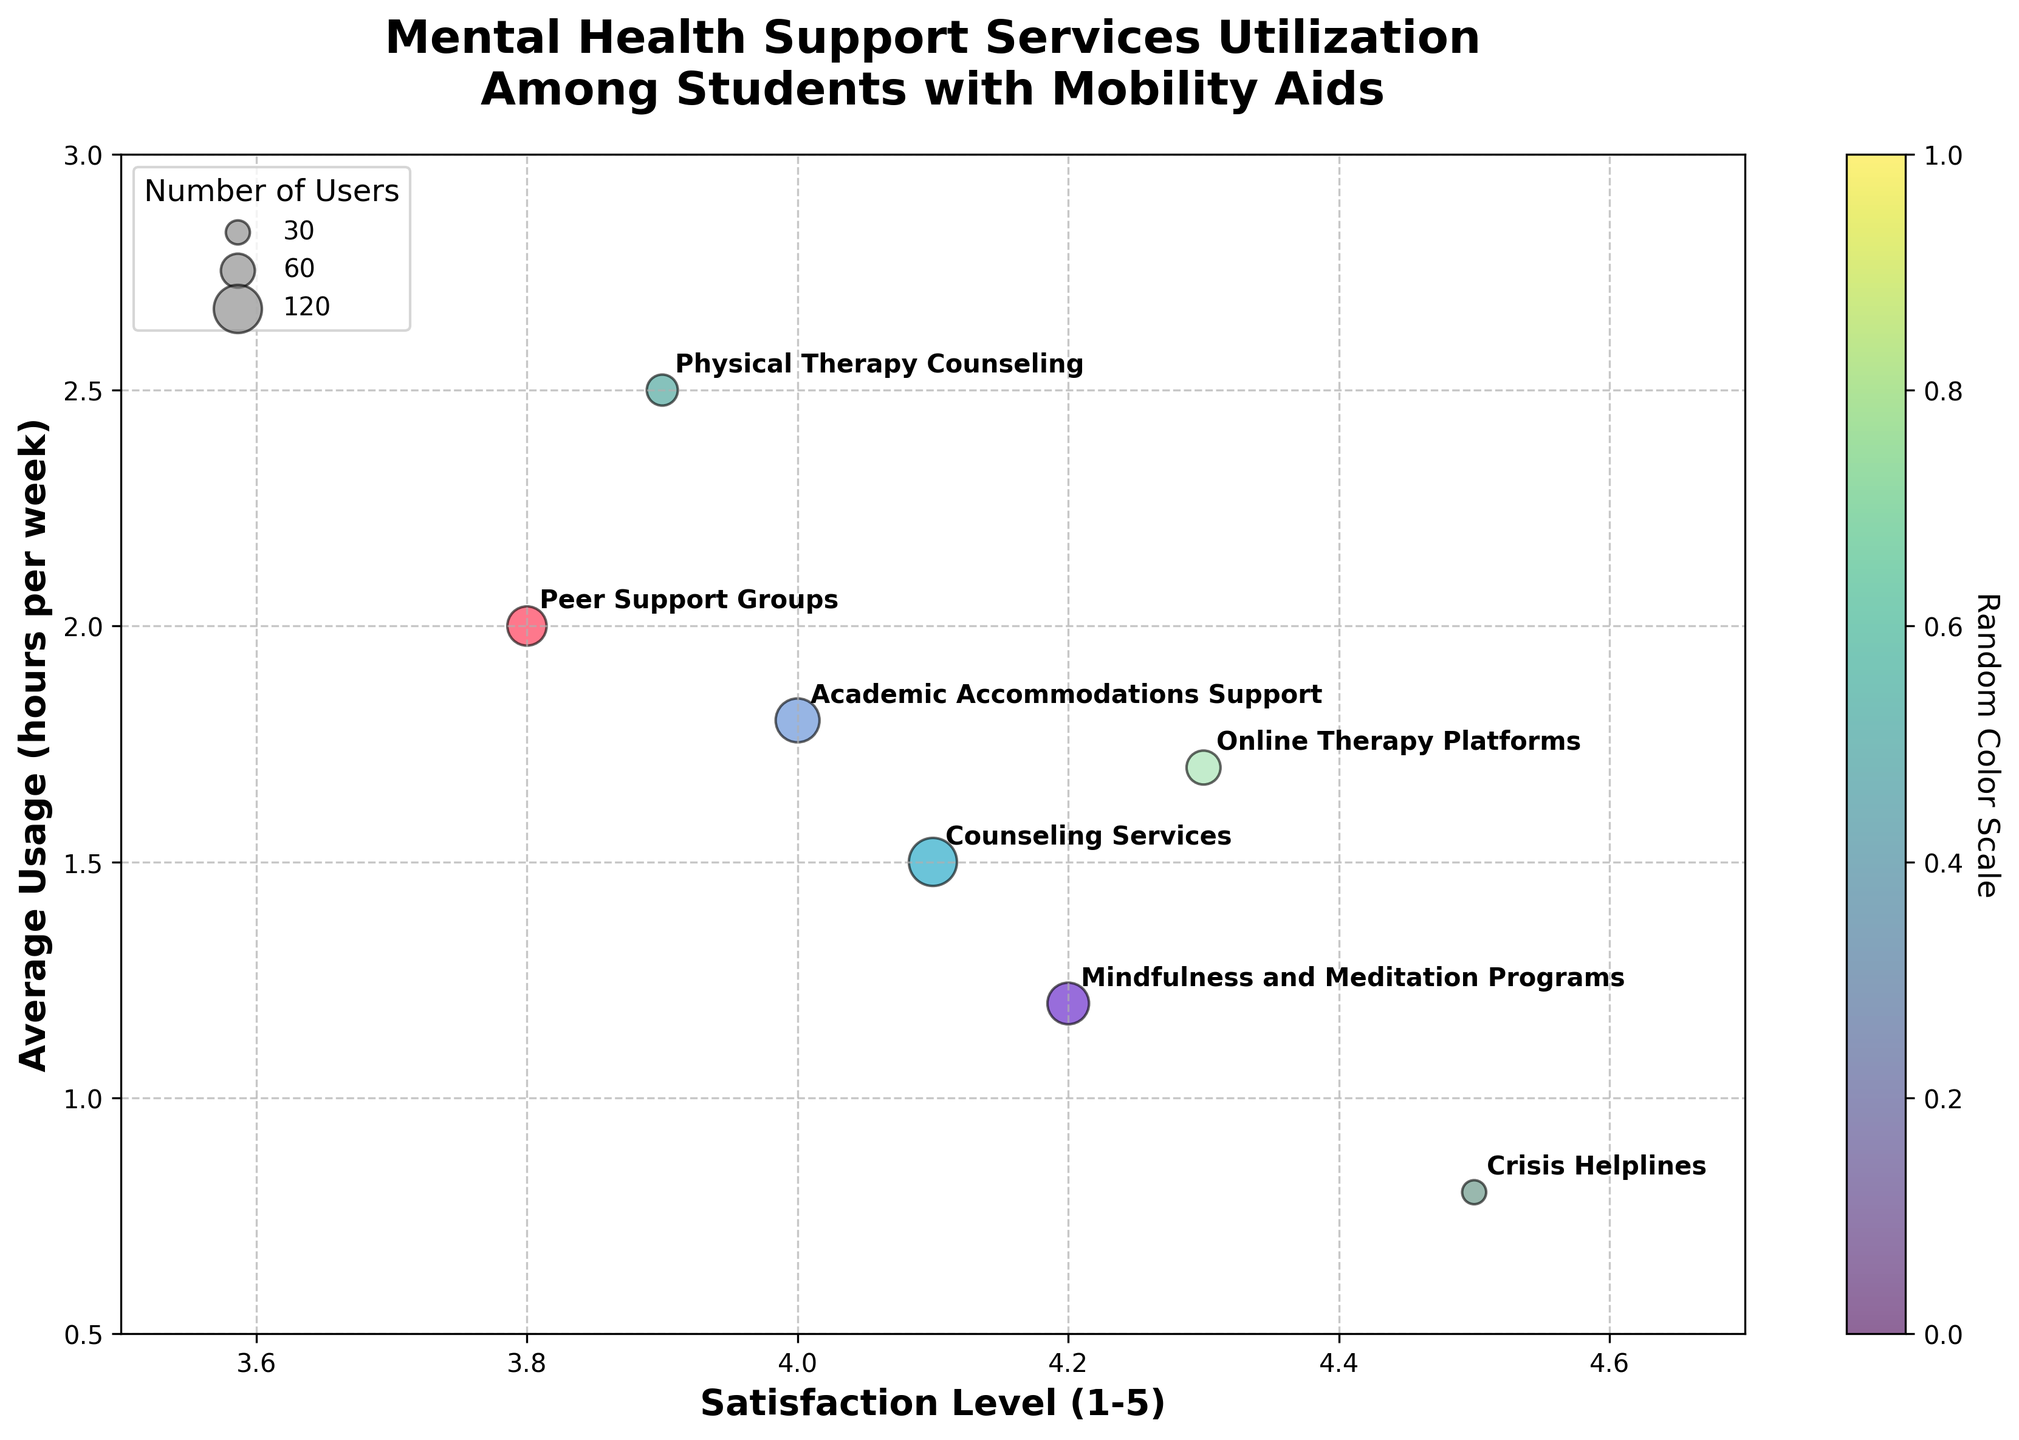What is the title of the chart? The title is located at the top of the chart. It reads 'Mental Health Support Services Utilization Among Students with Mobility Aids'. This provides context about the subject of the data presented.
Answer: Mental Health Support Services Utilization Among Students with Mobility Aids What is the range of the satisfaction levels on the x-axis? The x-axis ranges from 3.5 to 4.7, as indicated by the tick marks and axis limits. These values represent the satisfaction levels.
Answer: 3.5 to 4.7 Which service has the highest satisfaction level? The highest satisfaction level on the x-axis is 4.5. By checking the annotation, it's clear that 'Crisis Helplines' corresponds to this value.
Answer: Crisis Helplines Which bubble represents the service with the largest number of users? The largest bubble size signifies the service with 120 users, as indicated in the size legend. By comparing this size among the bubbles and reading the annotation, 'Counseling Services' matches this criterion.
Answer: Counseling Services Which type of service is utilized the least per week? The y-axis indicates usage in hours per week. The lowest value shown is 0.8 hours. The bubble near this value is annotated as 'Crisis Helplines'.
Answer: Crisis Helplines What is the average weekly usage for 'Mindfulness and Meditation Programs'? The 'Mindfulness and Meditation Programs' bubble is annotated and situated at approximately 1.2 on the y-axis, denoting its average weekly usage.
Answer: 1.2 hours Compare the satisfaction level and average weekly usage between 'Counseling Services' and 'Academic Accommodations Support'. 'Counseling Services' has a satisfaction level of 4.1 and an average usage of 1.5 hours per week. 'Academic Accommodations Support' has a satisfaction level of 4.0 and an average usage of 1.8 hours. Counseling Services has a slightly higher satisfaction level, while Academic Accommodations Support has higher usage per week.
Answer: Counseling Services: 4.1 satisfaction, 1.5 hours; Academic Accommodations Support: 4.0 satisfaction, 1.8 hours Which service is both above average in terms of satisfaction level and weekly usage? The average satisfaction level can be approximated by examining the mid-point of the x-axis range (around 4.1), and the average usage by the mid-point of the y-axis (around 1.5 hours). 'Peer Support Groups' has a satisfaction level of 3.8 and usage of 2.0 hours – above average in usage but below in satisfaction. 'Online Therapy Platforms' and 'Physical Therapy Counseling' both sit above these averages in their respective bubbles.
Answer: Online Therapy Platforms and Physical Therapy Counseling How many types of services have a satisfaction level greater than 4? Looking at the x-axis and identifying bubbles annotated with satisfaction levels above 4, we find 'Counseling Services', 'Online Therapy Platforms', 'Crisis Helplines', and 'Mindfulness and Meditation Programs'. Counting these annotations, there are four services.
Answer: 4 What does the color of the bubbles represent? The scatter plot includes a colorbar labeled 'Random Color Scale', suggesting that the colors do not represent any specific variable but are random. The differentiation is purely for visual differentiation.
Answer: Random allocation Which type of service has the highest average usage per week? The y-axis measures usage in hours per week. The highest value on this axis is 2.5. Comparing this with the annotations, it corresponds to 'Physical Therapy Counseling'.
Answer: Physical Therapy Counseling 